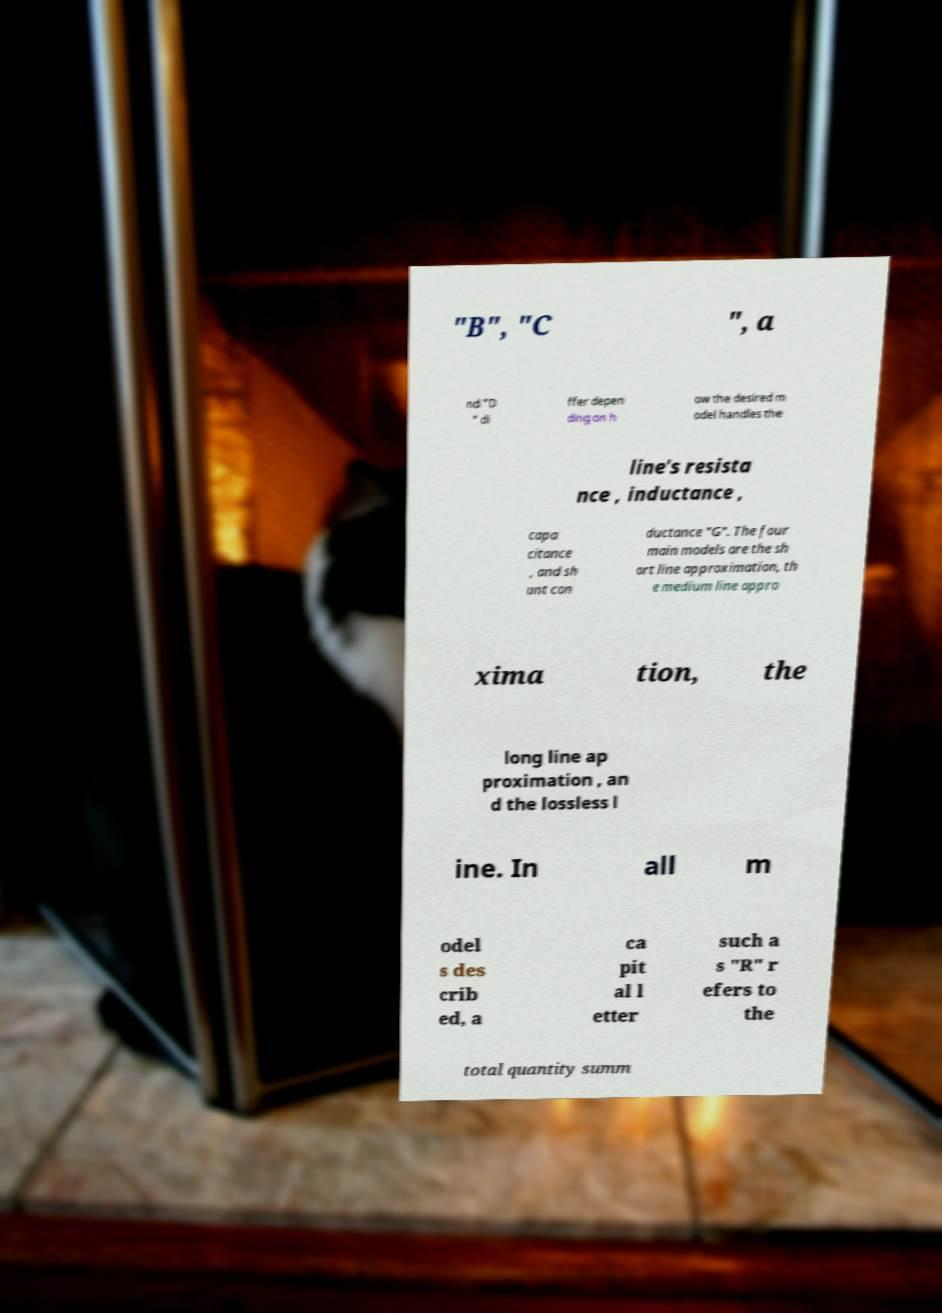I need the written content from this picture converted into text. Can you do that? "B", "C ", a nd "D " di ffer depen ding on h ow the desired m odel handles the line's resista nce , inductance , capa citance , and sh unt con ductance "G". The four main models are the sh ort line approximation, th e medium line appro xima tion, the long line ap proximation , an d the lossless l ine. In all m odel s des crib ed, a ca pit al l etter such a s "R" r efers to the total quantity summ 